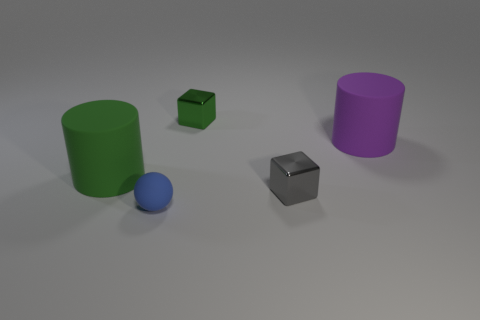What is the large green cylinder made of?
Provide a short and direct response. Rubber. How many things are either matte objects on the left side of the small green shiny thing or metallic cubes behind the gray block?
Your answer should be very brief. 3. What number of other objects are the same color as the matte sphere?
Give a very brief answer. 0. There is a large green object; is its shape the same as the small shiny object that is to the right of the tiny green metallic cube?
Your answer should be very brief. No. Is the number of tiny blue rubber balls right of the small gray object less than the number of tiny matte things that are behind the large purple rubber thing?
Provide a succinct answer. No. There is a green thing that is the same shape as the purple rubber thing; what is it made of?
Your answer should be compact. Rubber. Is there anything else that has the same material as the large purple thing?
Offer a very short reply. Yes. What is the shape of the large green object that is the same material as the large purple cylinder?
Offer a very short reply. Cylinder. How many purple matte objects are the same shape as the green matte object?
Keep it short and to the point. 1. There is a small metal thing in front of the tiny green shiny object on the left side of the purple cylinder; what is its shape?
Offer a terse response. Cube. 